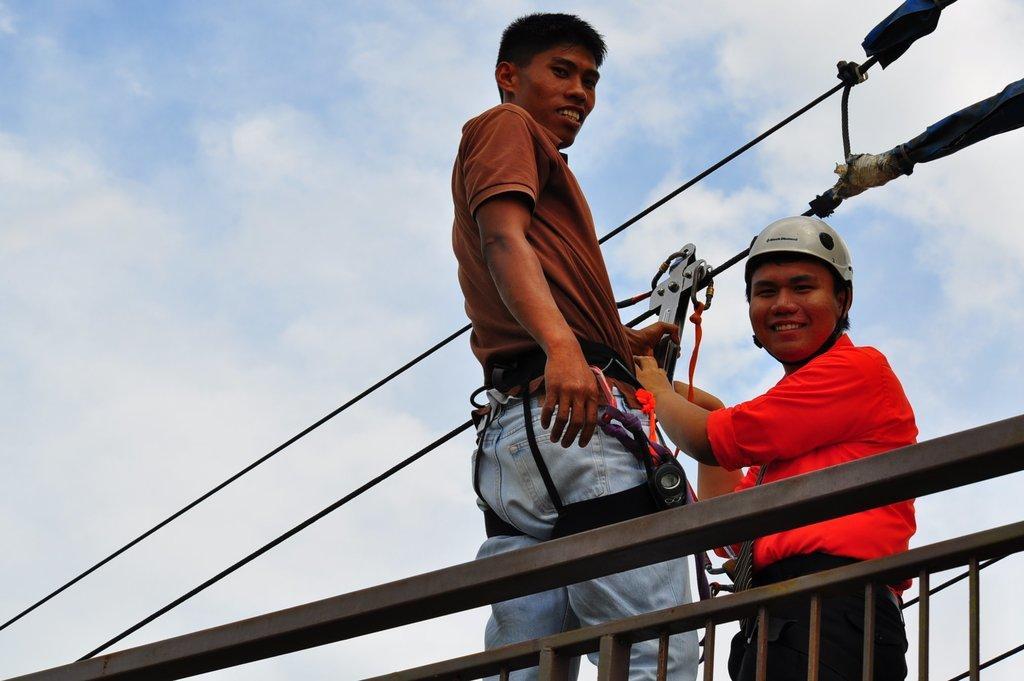Can you describe this image briefly? The person wearing red dress is holding an object which is attached to a wire above it and there is another person standing beside him and there is a fence beside them. 